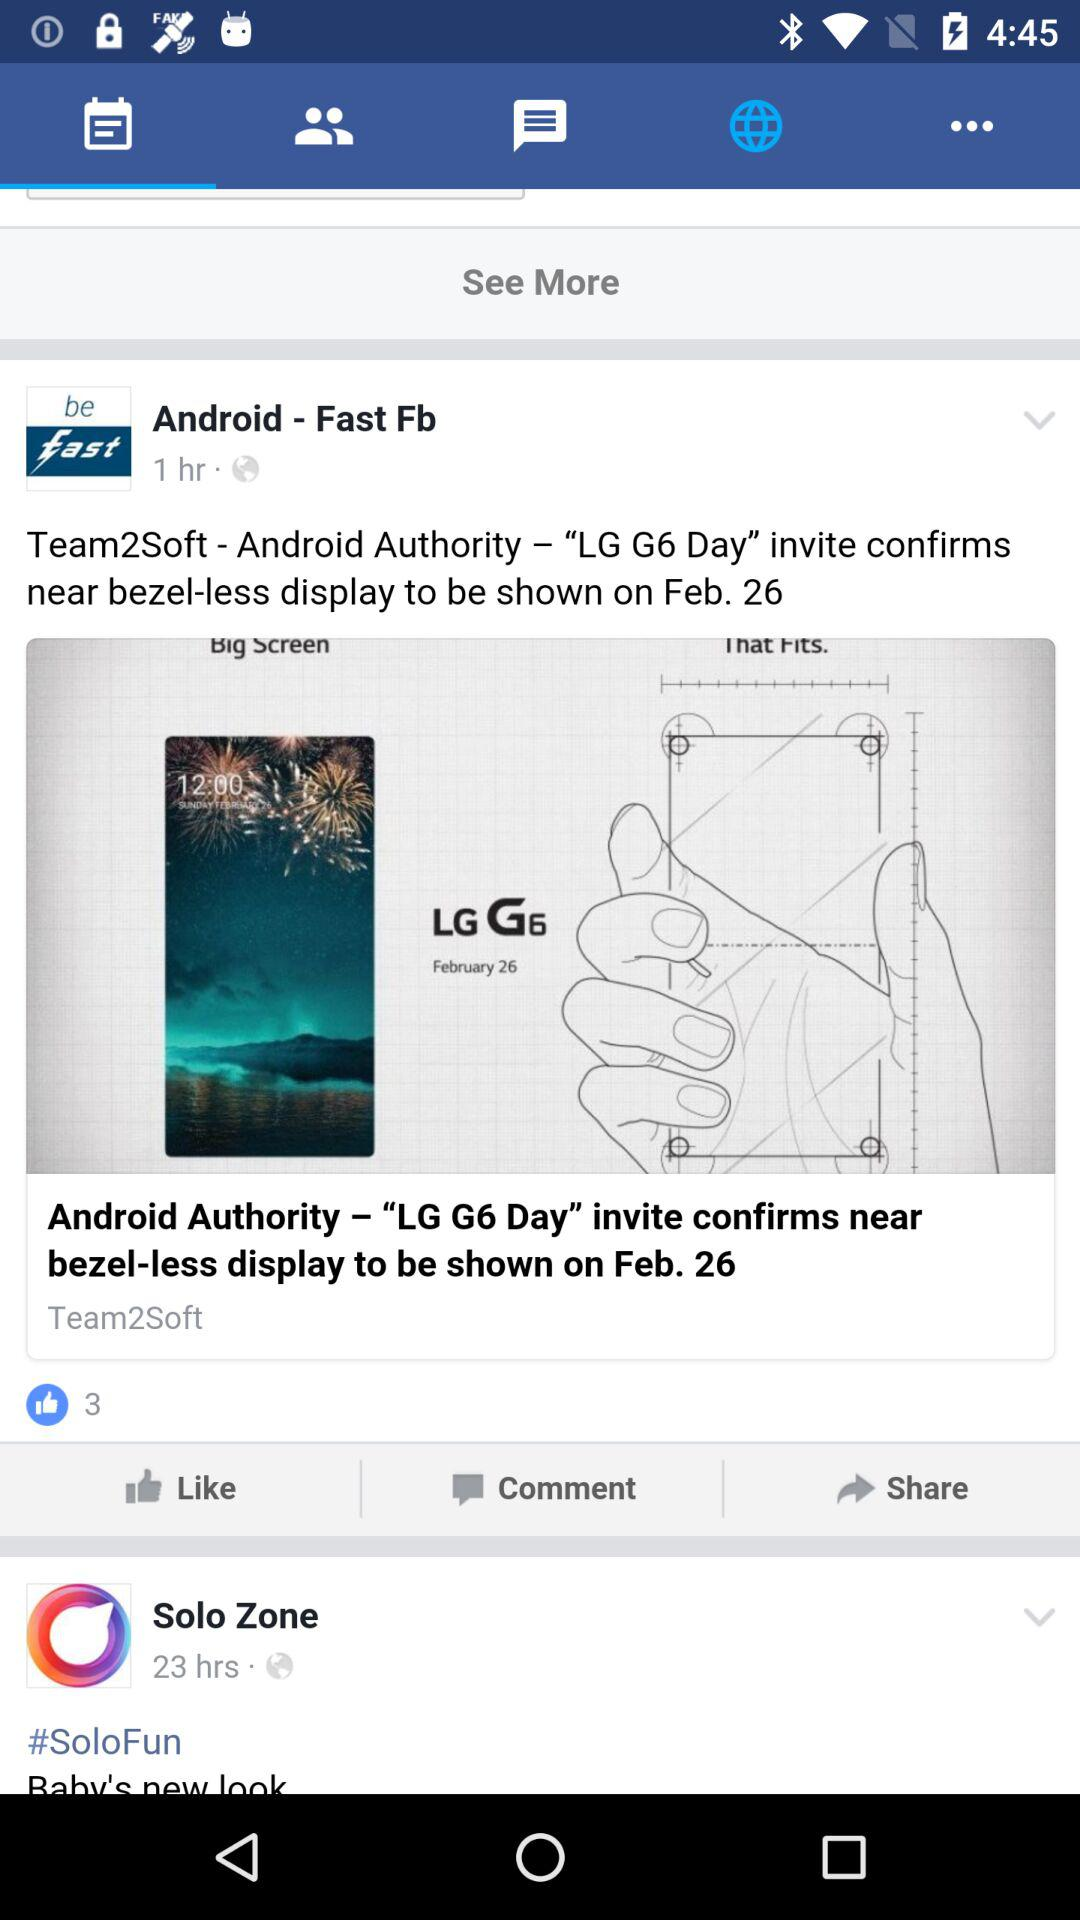How many hours ago was the post updated by "Android - Fast Fb"? The post was updated 1 hour ago. 